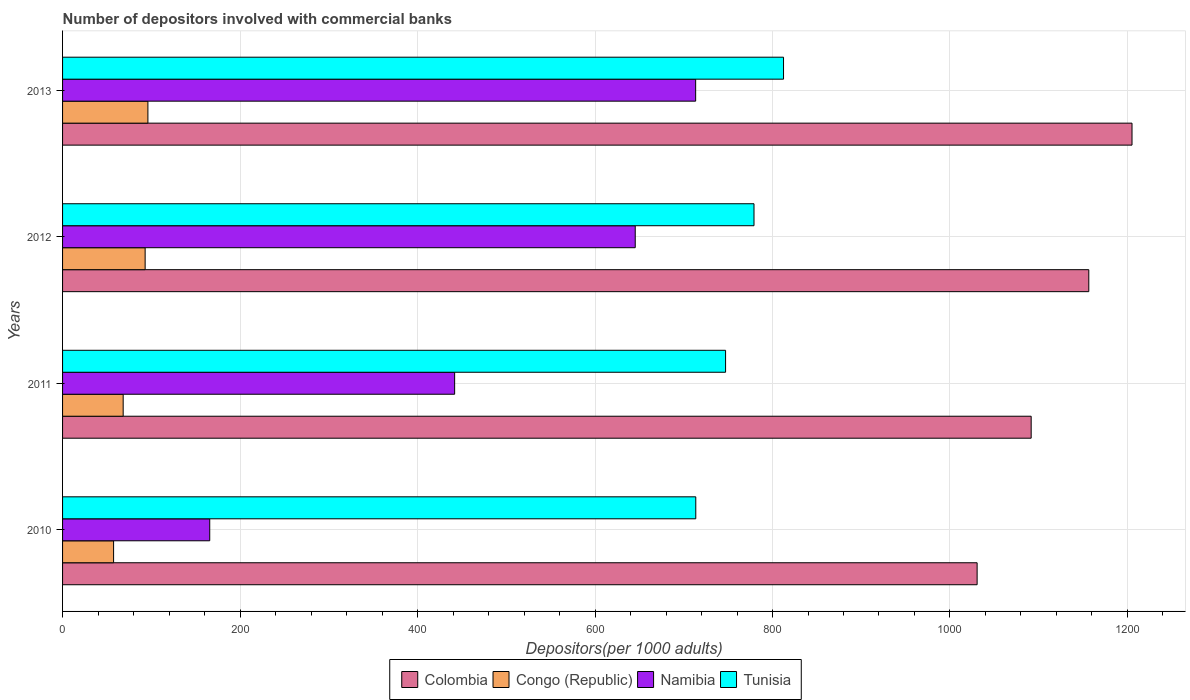How many groups of bars are there?
Your response must be concise. 4. Are the number of bars per tick equal to the number of legend labels?
Your answer should be compact. Yes. How many bars are there on the 2nd tick from the top?
Provide a succinct answer. 4. What is the label of the 1st group of bars from the top?
Keep it short and to the point. 2013. What is the number of depositors involved with commercial banks in Tunisia in 2012?
Ensure brevity in your answer.  779.16. Across all years, what is the maximum number of depositors involved with commercial banks in Namibia?
Offer a very short reply. 713.41. Across all years, what is the minimum number of depositors involved with commercial banks in Tunisia?
Your answer should be very brief. 713.56. In which year was the number of depositors involved with commercial banks in Tunisia maximum?
Ensure brevity in your answer.  2013. What is the total number of depositors involved with commercial banks in Congo (Republic) in the graph?
Offer a very short reply. 315.01. What is the difference between the number of depositors involved with commercial banks in Namibia in 2011 and that in 2013?
Your response must be concise. -271.59. What is the difference between the number of depositors involved with commercial banks in Namibia in 2010 and the number of depositors involved with commercial banks in Tunisia in 2013?
Your response must be concise. -646.59. What is the average number of depositors involved with commercial banks in Namibia per year?
Provide a short and direct response. 491.6. In the year 2011, what is the difference between the number of depositors involved with commercial banks in Congo (Republic) and number of depositors involved with commercial banks in Namibia?
Keep it short and to the point. -373.52. In how many years, is the number of depositors involved with commercial banks in Colombia greater than 320 ?
Provide a succinct answer. 4. What is the ratio of the number of depositors involved with commercial banks in Tunisia in 2010 to that in 2012?
Ensure brevity in your answer.  0.92. Is the number of depositors involved with commercial banks in Namibia in 2010 less than that in 2011?
Your answer should be compact. Yes. What is the difference between the highest and the second highest number of depositors involved with commercial banks in Congo (Republic)?
Your response must be concise. 3.11. What is the difference between the highest and the lowest number of depositors involved with commercial banks in Tunisia?
Make the answer very short. 98.87. In how many years, is the number of depositors involved with commercial banks in Tunisia greater than the average number of depositors involved with commercial banks in Tunisia taken over all years?
Make the answer very short. 2. Is the sum of the number of depositors involved with commercial banks in Namibia in 2010 and 2012 greater than the maximum number of depositors involved with commercial banks in Tunisia across all years?
Give a very brief answer. No. What does the 2nd bar from the top in 2011 represents?
Provide a succinct answer. Namibia. What does the 3rd bar from the bottom in 2011 represents?
Provide a succinct answer. Namibia. How many bars are there?
Offer a terse response. 16. Are all the bars in the graph horizontal?
Your answer should be compact. Yes. How are the legend labels stacked?
Provide a succinct answer. Horizontal. What is the title of the graph?
Your answer should be very brief. Number of depositors involved with commercial banks. Does "Isle of Man" appear as one of the legend labels in the graph?
Provide a succinct answer. No. What is the label or title of the X-axis?
Your answer should be very brief. Depositors(per 1000 adults). What is the label or title of the Y-axis?
Your response must be concise. Years. What is the Depositors(per 1000 adults) of Colombia in 2010?
Provide a succinct answer. 1030.59. What is the Depositors(per 1000 adults) of Congo (Republic) in 2010?
Ensure brevity in your answer.  57.5. What is the Depositors(per 1000 adults) in Namibia in 2010?
Offer a terse response. 165.83. What is the Depositors(per 1000 adults) of Tunisia in 2010?
Provide a short and direct response. 713.56. What is the Depositors(per 1000 adults) of Colombia in 2011?
Provide a short and direct response. 1091.5. What is the Depositors(per 1000 adults) in Congo (Republic) in 2011?
Keep it short and to the point. 68.3. What is the Depositors(per 1000 adults) in Namibia in 2011?
Keep it short and to the point. 441.82. What is the Depositors(per 1000 adults) in Tunisia in 2011?
Provide a succinct answer. 747.13. What is the Depositors(per 1000 adults) in Colombia in 2012?
Your response must be concise. 1156.43. What is the Depositors(per 1000 adults) of Congo (Republic) in 2012?
Make the answer very short. 93.05. What is the Depositors(per 1000 adults) of Namibia in 2012?
Your answer should be compact. 645.33. What is the Depositors(per 1000 adults) in Tunisia in 2012?
Keep it short and to the point. 779.16. What is the Depositors(per 1000 adults) in Colombia in 2013?
Keep it short and to the point. 1205.13. What is the Depositors(per 1000 adults) in Congo (Republic) in 2013?
Make the answer very short. 96.16. What is the Depositors(per 1000 adults) of Namibia in 2013?
Your response must be concise. 713.41. What is the Depositors(per 1000 adults) in Tunisia in 2013?
Ensure brevity in your answer.  812.43. Across all years, what is the maximum Depositors(per 1000 adults) of Colombia?
Your answer should be very brief. 1205.13. Across all years, what is the maximum Depositors(per 1000 adults) in Congo (Republic)?
Make the answer very short. 96.16. Across all years, what is the maximum Depositors(per 1000 adults) in Namibia?
Ensure brevity in your answer.  713.41. Across all years, what is the maximum Depositors(per 1000 adults) in Tunisia?
Offer a very short reply. 812.43. Across all years, what is the minimum Depositors(per 1000 adults) in Colombia?
Offer a terse response. 1030.59. Across all years, what is the minimum Depositors(per 1000 adults) in Congo (Republic)?
Make the answer very short. 57.5. Across all years, what is the minimum Depositors(per 1000 adults) of Namibia?
Provide a short and direct response. 165.83. Across all years, what is the minimum Depositors(per 1000 adults) of Tunisia?
Offer a very short reply. 713.56. What is the total Depositors(per 1000 adults) of Colombia in the graph?
Ensure brevity in your answer.  4483.65. What is the total Depositors(per 1000 adults) of Congo (Republic) in the graph?
Keep it short and to the point. 315.01. What is the total Depositors(per 1000 adults) in Namibia in the graph?
Your answer should be compact. 1966.4. What is the total Depositors(per 1000 adults) in Tunisia in the graph?
Offer a terse response. 3052.28. What is the difference between the Depositors(per 1000 adults) of Colombia in 2010 and that in 2011?
Keep it short and to the point. -60.9. What is the difference between the Depositors(per 1000 adults) of Congo (Republic) in 2010 and that in 2011?
Give a very brief answer. -10.8. What is the difference between the Depositors(per 1000 adults) of Namibia in 2010 and that in 2011?
Provide a succinct answer. -275.99. What is the difference between the Depositors(per 1000 adults) in Tunisia in 2010 and that in 2011?
Your response must be concise. -33.57. What is the difference between the Depositors(per 1000 adults) of Colombia in 2010 and that in 2012?
Give a very brief answer. -125.84. What is the difference between the Depositors(per 1000 adults) of Congo (Republic) in 2010 and that in 2012?
Make the answer very short. -35.55. What is the difference between the Depositors(per 1000 adults) in Namibia in 2010 and that in 2012?
Offer a terse response. -479.5. What is the difference between the Depositors(per 1000 adults) of Tunisia in 2010 and that in 2012?
Your answer should be compact. -65.61. What is the difference between the Depositors(per 1000 adults) of Colombia in 2010 and that in 2013?
Your answer should be very brief. -174.54. What is the difference between the Depositors(per 1000 adults) of Congo (Republic) in 2010 and that in 2013?
Keep it short and to the point. -38.66. What is the difference between the Depositors(per 1000 adults) of Namibia in 2010 and that in 2013?
Make the answer very short. -547.58. What is the difference between the Depositors(per 1000 adults) in Tunisia in 2010 and that in 2013?
Make the answer very short. -98.87. What is the difference between the Depositors(per 1000 adults) in Colombia in 2011 and that in 2012?
Offer a very short reply. -64.94. What is the difference between the Depositors(per 1000 adults) in Congo (Republic) in 2011 and that in 2012?
Make the answer very short. -24.74. What is the difference between the Depositors(per 1000 adults) of Namibia in 2011 and that in 2012?
Provide a short and direct response. -203.51. What is the difference between the Depositors(per 1000 adults) of Tunisia in 2011 and that in 2012?
Offer a very short reply. -32.03. What is the difference between the Depositors(per 1000 adults) of Colombia in 2011 and that in 2013?
Your answer should be very brief. -113.64. What is the difference between the Depositors(per 1000 adults) of Congo (Republic) in 2011 and that in 2013?
Keep it short and to the point. -27.86. What is the difference between the Depositors(per 1000 adults) in Namibia in 2011 and that in 2013?
Your response must be concise. -271.59. What is the difference between the Depositors(per 1000 adults) of Tunisia in 2011 and that in 2013?
Provide a short and direct response. -65.3. What is the difference between the Depositors(per 1000 adults) in Colombia in 2012 and that in 2013?
Your answer should be very brief. -48.7. What is the difference between the Depositors(per 1000 adults) in Congo (Republic) in 2012 and that in 2013?
Offer a terse response. -3.11. What is the difference between the Depositors(per 1000 adults) of Namibia in 2012 and that in 2013?
Make the answer very short. -68.08. What is the difference between the Depositors(per 1000 adults) of Tunisia in 2012 and that in 2013?
Provide a short and direct response. -33.26. What is the difference between the Depositors(per 1000 adults) of Colombia in 2010 and the Depositors(per 1000 adults) of Congo (Republic) in 2011?
Offer a terse response. 962.29. What is the difference between the Depositors(per 1000 adults) in Colombia in 2010 and the Depositors(per 1000 adults) in Namibia in 2011?
Offer a terse response. 588.77. What is the difference between the Depositors(per 1000 adults) in Colombia in 2010 and the Depositors(per 1000 adults) in Tunisia in 2011?
Offer a very short reply. 283.46. What is the difference between the Depositors(per 1000 adults) in Congo (Republic) in 2010 and the Depositors(per 1000 adults) in Namibia in 2011?
Ensure brevity in your answer.  -384.32. What is the difference between the Depositors(per 1000 adults) in Congo (Republic) in 2010 and the Depositors(per 1000 adults) in Tunisia in 2011?
Keep it short and to the point. -689.63. What is the difference between the Depositors(per 1000 adults) of Namibia in 2010 and the Depositors(per 1000 adults) of Tunisia in 2011?
Offer a very short reply. -581.29. What is the difference between the Depositors(per 1000 adults) of Colombia in 2010 and the Depositors(per 1000 adults) of Congo (Republic) in 2012?
Your answer should be compact. 937.54. What is the difference between the Depositors(per 1000 adults) of Colombia in 2010 and the Depositors(per 1000 adults) of Namibia in 2012?
Provide a succinct answer. 385.26. What is the difference between the Depositors(per 1000 adults) in Colombia in 2010 and the Depositors(per 1000 adults) in Tunisia in 2012?
Offer a terse response. 251.43. What is the difference between the Depositors(per 1000 adults) in Congo (Republic) in 2010 and the Depositors(per 1000 adults) in Namibia in 2012?
Provide a succinct answer. -587.83. What is the difference between the Depositors(per 1000 adults) in Congo (Republic) in 2010 and the Depositors(per 1000 adults) in Tunisia in 2012?
Offer a terse response. -721.66. What is the difference between the Depositors(per 1000 adults) of Namibia in 2010 and the Depositors(per 1000 adults) of Tunisia in 2012?
Keep it short and to the point. -613.33. What is the difference between the Depositors(per 1000 adults) in Colombia in 2010 and the Depositors(per 1000 adults) in Congo (Republic) in 2013?
Give a very brief answer. 934.43. What is the difference between the Depositors(per 1000 adults) of Colombia in 2010 and the Depositors(per 1000 adults) of Namibia in 2013?
Your response must be concise. 317.18. What is the difference between the Depositors(per 1000 adults) in Colombia in 2010 and the Depositors(per 1000 adults) in Tunisia in 2013?
Offer a terse response. 218.17. What is the difference between the Depositors(per 1000 adults) in Congo (Republic) in 2010 and the Depositors(per 1000 adults) in Namibia in 2013?
Make the answer very short. -655.91. What is the difference between the Depositors(per 1000 adults) in Congo (Republic) in 2010 and the Depositors(per 1000 adults) in Tunisia in 2013?
Offer a very short reply. -754.93. What is the difference between the Depositors(per 1000 adults) in Namibia in 2010 and the Depositors(per 1000 adults) in Tunisia in 2013?
Give a very brief answer. -646.59. What is the difference between the Depositors(per 1000 adults) of Colombia in 2011 and the Depositors(per 1000 adults) of Congo (Republic) in 2012?
Make the answer very short. 998.45. What is the difference between the Depositors(per 1000 adults) of Colombia in 2011 and the Depositors(per 1000 adults) of Namibia in 2012?
Provide a succinct answer. 446.17. What is the difference between the Depositors(per 1000 adults) in Colombia in 2011 and the Depositors(per 1000 adults) in Tunisia in 2012?
Keep it short and to the point. 312.33. What is the difference between the Depositors(per 1000 adults) in Congo (Republic) in 2011 and the Depositors(per 1000 adults) in Namibia in 2012?
Keep it short and to the point. -577.03. What is the difference between the Depositors(per 1000 adults) of Congo (Republic) in 2011 and the Depositors(per 1000 adults) of Tunisia in 2012?
Your response must be concise. -710.86. What is the difference between the Depositors(per 1000 adults) in Namibia in 2011 and the Depositors(per 1000 adults) in Tunisia in 2012?
Offer a terse response. -337.34. What is the difference between the Depositors(per 1000 adults) in Colombia in 2011 and the Depositors(per 1000 adults) in Congo (Republic) in 2013?
Your answer should be compact. 995.34. What is the difference between the Depositors(per 1000 adults) in Colombia in 2011 and the Depositors(per 1000 adults) in Namibia in 2013?
Offer a terse response. 378.08. What is the difference between the Depositors(per 1000 adults) of Colombia in 2011 and the Depositors(per 1000 adults) of Tunisia in 2013?
Make the answer very short. 279.07. What is the difference between the Depositors(per 1000 adults) of Congo (Republic) in 2011 and the Depositors(per 1000 adults) of Namibia in 2013?
Provide a short and direct response. -645.11. What is the difference between the Depositors(per 1000 adults) in Congo (Republic) in 2011 and the Depositors(per 1000 adults) in Tunisia in 2013?
Your response must be concise. -744.12. What is the difference between the Depositors(per 1000 adults) of Namibia in 2011 and the Depositors(per 1000 adults) of Tunisia in 2013?
Keep it short and to the point. -370.6. What is the difference between the Depositors(per 1000 adults) in Colombia in 2012 and the Depositors(per 1000 adults) in Congo (Republic) in 2013?
Offer a very short reply. 1060.27. What is the difference between the Depositors(per 1000 adults) in Colombia in 2012 and the Depositors(per 1000 adults) in Namibia in 2013?
Provide a short and direct response. 443.02. What is the difference between the Depositors(per 1000 adults) in Colombia in 2012 and the Depositors(per 1000 adults) in Tunisia in 2013?
Provide a succinct answer. 344.01. What is the difference between the Depositors(per 1000 adults) of Congo (Republic) in 2012 and the Depositors(per 1000 adults) of Namibia in 2013?
Your response must be concise. -620.36. What is the difference between the Depositors(per 1000 adults) in Congo (Republic) in 2012 and the Depositors(per 1000 adults) in Tunisia in 2013?
Make the answer very short. -719.38. What is the difference between the Depositors(per 1000 adults) in Namibia in 2012 and the Depositors(per 1000 adults) in Tunisia in 2013?
Ensure brevity in your answer.  -167.1. What is the average Depositors(per 1000 adults) in Colombia per year?
Ensure brevity in your answer.  1120.91. What is the average Depositors(per 1000 adults) in Congo (Republic) per year?
Keep it short and to the point. 78.75. What is the average Depositors(per 1000 adults) in Namibia per year?
Your answer should be very brief. 491.6. What is the average Depositors(per 1000 adults) of Tunisia per year?
Give a very brief answer. 763.07. In the year 2010, what is the difference between the Depositors(per 1000 adults) of Colombia and Depositors(per 1000 adults) of Congo (Republic)?
Your response must be concise. 973.09. In the year 2010, what is the difference between the Depositors(per 1000 adults) of Colombia and Depositors(per 1000 adults) of Namibia?
Give a very brief answer. 864.76. In the year 2010, what is the difference between the Depositors(per 1000 adults) in Colombia and Depositors(per 1000 adults) in Tunisia?
Your answer should be very brief. 317.03. In the year 2010, what is the difference between the Depositors(per 1000 adults) in Congo (Republic) and Depositors(per 1000 adults) in Namibia?
Your answer should be very brief. -108.33. In the year 2010, what is the difference between the Depositors(per 1000 adults) in Congo (Republic) and Depositors(per 1000 adults) in Tunisia?
Your answer should be very brief. -656.06. In the year 2010, what is the difference between the Depositors(per 1000 adults) in Namibia and Depositors(per 1000 adults) in Tunisia?
Your response must be concise. -547.72. In the year 2011, what is the difference between the Depositors(per 1000 adults) in Colombia and Depositors(per 1000 adults) in Congo (Republic)?
Your answer should be very brief. 1023.19. In the year 2011, what is the difference between the Depositors(per 1000 adults) in Colombia and Depositors(per 1000 adults) in Namibia?
Provide a succinct answer. 649.67. In the year 2011, what is the difference between the Depositors(per 1000 adults) in Colombia and Depositors(per 1000 adults) in Tunisia?
Your answer should be compact. 344.37. In the year 2011, what is the difference between the Depositors(per 1000 adults) in Congo (Republic) and Depositors(per 1000 adults) in Namibia?
Ensure brevity in your answer.  -373.52. In the year 2011, what is the difference between the Depositors(per 1000 adults) of Congo (Republic) and Depositors(per 1000 adults) of Tunisia?
Keep it short and to the point. -678.83. In the year 2011, what is the difference between the Depositors(per 1000 adults) in Namibia and Depositors(per 1000 adults) in Tunisia?
Your response must be concise. -305.31. In the year 2012, what is the difference between the Depositors(per 1000 adults) of Colombia and Depositors(per 1000 adults) of Congo (Republic)?
Offer a terse response. 1063.38. In the year 2012, what is the difference between the Depositors(per 1000 adults) in Colombia and Depositors(per 1000 adults) in Namibia?
Make the answer very short. 511.1. In the year 2012, what is the difference between the Depositors(per 1000 adults) of Colombia and Depositors(per 1000 adults) of Tunisia?
Make the answer very short. 377.27. In the year 2012, what is the difference between the Depositors(per 1000 adults) of Congo (Republic) and Depositors(per 1000 adults) of Namibia?
Provide a short and direct response. -552.28. In the year 2012, what is the difference between the Depositors(per 1000 adults) in Congo (Republic) and Depositors(per 1000 adults) in Tunisia?
Your answer should be very brief. -686.12. In the year 2012, what is the difference between the Depositors(per 1000 adults) of Namibia and Depositors(per 1000 adults) of Tunisia?
Your answer should be very brief. -133.83. In the year 2013, what is the difference between the Depositors(per 1000 adults) in Colombia and Depositors(per 1000 adults) in Congo (Republic)?
Your answer should be compact. 1108.97. In the year 2013, what is the difference between the Depositors(per 1000 adults) in Colombia and Depositors(per 1000 adults) in Namibia?
Your answer should be compact. 491.72. In the year 2013, what is the difference between the Depositors(per 1000 adults) in Colombia and Depositors(per 1000 adults) in Tunisia?
Offer a terse response. 392.71. In the year 2013, what is the difference between the Depositors(per 1000 adults) of Congo (Republic) and Depositors(per 1000 adults) of Namibia?
Ensure brevity in your answer.  -617.25. In the year 2013, what is the difference between the Depositors(per 1000 adults) in Congo (Republic) and Depositors(per 1000 adults) in Tunisia?
Your answer should be compact. -716.27. In the year 2013, what is the difference between the Depositors(per 1000 adults) of Namibia and Depositors(per 1000 adults) of Tunisia?
Your answer should be very brief. -99.01. What is the ratio of the Depositors(per 1000 adults) of Colombia in 2010 to that in 2011?
Offer a terse response. 0.94. What is the ratio of the Depositors(per 1000 adults) in Congo (Republic) in 2010 to that in 2011?
Your answer should be very brief. 0.84. What is the ratio of the Depositors(per 1000 adults) in Namibia in 2010 to that in 2011?
Your answer should be very brief. 0.38. What is the ratio of the Depositors(per 1000 adults) in Tunisia in 2010 to that in 2011?
Offer a very short reply. 0.96. What is the ratio of the Depositors(per 1000 adults) in Colombia in 2010 to that in 2012?
Your answer should be very brief. 0.89. What is the ratio of the Depositors(per 1000 adults) in Congo (Republic) in 2010 to that in 2012?
Offer a terse response. 0.62. What is the ratio of the Depositors(per 1000 adults) of Namibia in 2010 to that in 2012?
Provide a succinct answer. 0.26. What is the ratio of the Depositors(per 1000 adults) in Tunisia in 2010 to that in 2012?
Your answer should be very brief. 0.92. What is the ratio of the Depositors(per 1000 adults) in Colombia in 2010 to that in 2013?
Ensure brevity in your answer.  0.86. What is the ratio of the Depositors(per 1000 adults) of Congo (Republic) in 2010 to that in 2013?
Your answer should be compact. 0.6. What is the ratio of the Depositors(per 1000 adults) in Namibia in 2010 to that in 2013?
Make the answer very short. 0.23. What is the ratio of the Depositors(per 1000 adults) in Tunisia in 2010 to that in 2013?
Your answer should be compact. 0.88. What is the ratio of the Depositors(per 1000 adults) in Colombia in 2011 to that in 2012?
Keep it short and to the point. 0.94. What is the ratio of the Depositors(per 1000 adults) in Congo (Republic) in 2011 to that in 2012?
Make the answer very short. 0.73. What is the ratio of the Depositors(per 1000 adults) of Namibia in 2011 to that in 2012?
Give a very brief answer. 0.68. What is the ratio of the Depositors(per 1000 adults) in Tunisia in 2011 to that in 2012?
Your answer should be compact. 0.96. What is the ratio of the Depositors(per 1000 adults) in Colombia in 2011 to that in 2013?
Your response must be concise. 0.91. What is the ratio of the Depositors(per 1000 adults) of Congo (Republic) in 2011 to that in 2013?
Provide a short and direct response. 0.71. What is the ratio of the Depositors(per 1000 adults) of Namibia in 2011 to that in 2013?
Your answer should be very brief. 0.62. What is the ratio of the Depositors(per 1000 adults) in Tunisia in 2011 to that in 2013?
Your answer should be very brief. 0.92. What is the ratio of the Depositors(per 1000 adults) in Colombia in 2012 to that in 2013?
Your answer should be very brief. 0.96. What is the ratio of the Depositors(per 1000 adults) of Congo (Republic) in 2012 to that in 2013?
Your answer should be very brief. 0.97. What is the ratio of the Depositors(per 1000 adults) in Namibia in 2012 to that in 2013?
Provide a succinct answer. 0.9. What is the ratio of the Depositors(per 1000 adults) of Tunisia in 2012 to that in 2013?
Make the answer very short. 0.96. What is the difference between the highest and the second highest Depositors(per 1000 adults) of Colombia?
Provide a succinct answer. 48.7. What is the difference between the highest and the second highest Depositors(per 1000 adults) in Congo (Republic)?
Your response must be concise. 3.11. What is the difference between the highest and the second highest Depositors(per 1000 adults) of Namibia?
Make the answer very short. 68.08. What is the difference between the highest and the second highest Depositors(per 1000 adults) of Tunisia?
Provide a succinct answer. 33.26. What is the difference between the highest and the lowest Depositors(per 1000 adults) of Colombia?
Provide a short and direct response. 174.54. What is the difference between the highest and the lowest Depositors(per 1000 adults) in Congo (Republic)?
Provide a short and direct response. 38.66. What is the difference between the highest and the lowest Depositors(per 1000 adults) in Namibia?
Offer a very short reply. 547.58. What is the difference between the highest and the lowest Depositors(per 1000 adults) in Tunisia?
Give a very brief answer. 98.87. 